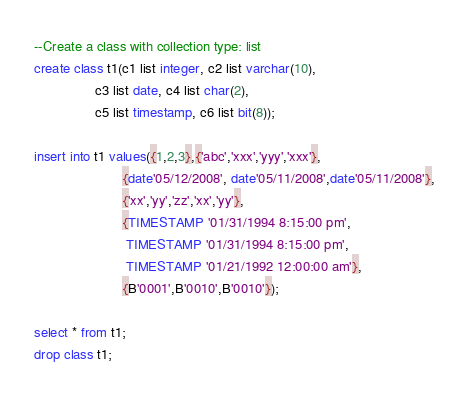<code> <loc_0><loc_0><loc_500><loc_500><_SQL_>--Create a class with collection type: list
create class t1(c1 list integer, c2 list varchar(10), 
                c3 list date, c4 list char(2),
                c5 list timestamp, c6 list bit(8));

insert into t1 values({1,2,3},{'abc','xxx','yyy','xxx'},
                       {date'05/12/2008', date'05/11/2008',date'05/11/2008'},
                       {'xx','yy','zz','xx','yy'},
                       {TIMESTAMP '01/31/1994 8:15:00 pm',
                        TIMESTAMP '01/31/1994 8:15:00 pm',
                        TIMESTAMP '01/21/1992 12:00:00 am'},
                       {B'0001',B'0010',B'0010'});
                       
select * from t1;
drop class t1;</code> 